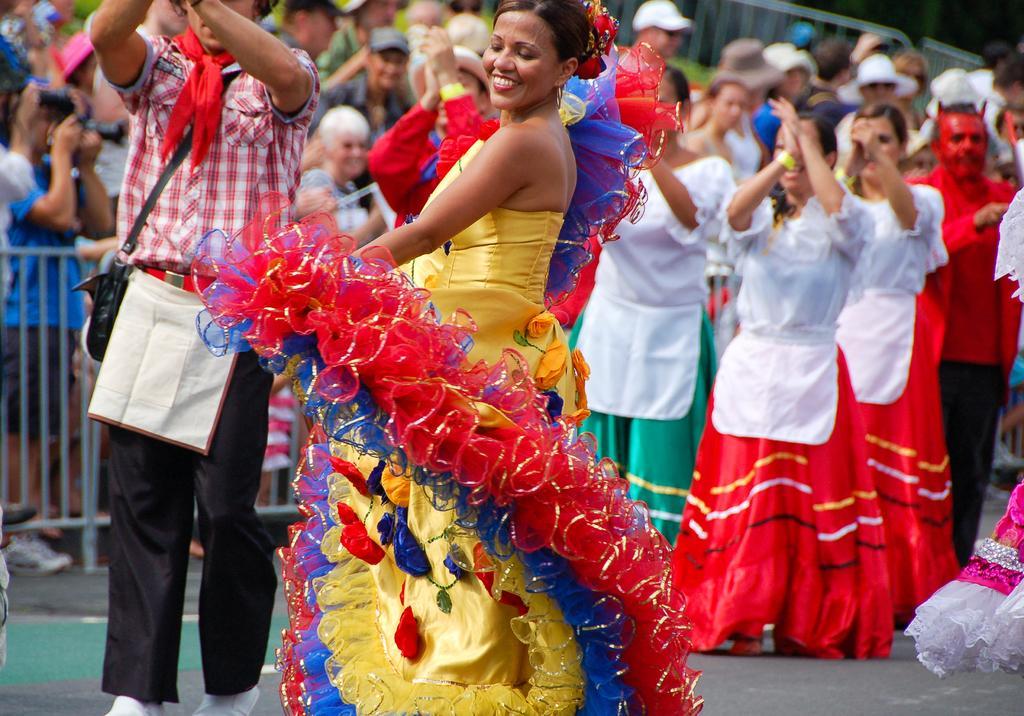Could you give a brief overview of what you see in this image? This is an outside view. In the middle of the image there is a woman wearing costume, smiling and dancing on the road. On the left side there is a man standing. In the background, I can see a crowd of people standing, smiling and clapping their hands by looking at this woman. On the left side there is a railing. 